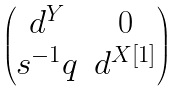<formula> <loc_0><loc_0><loc_500><loc_500>\begin{pmatrix} d ^ { Y } & 0 \\ s ^ { - 1 } q & d ^ { X [ 1 ] } \end{pmatrix}</formula> 